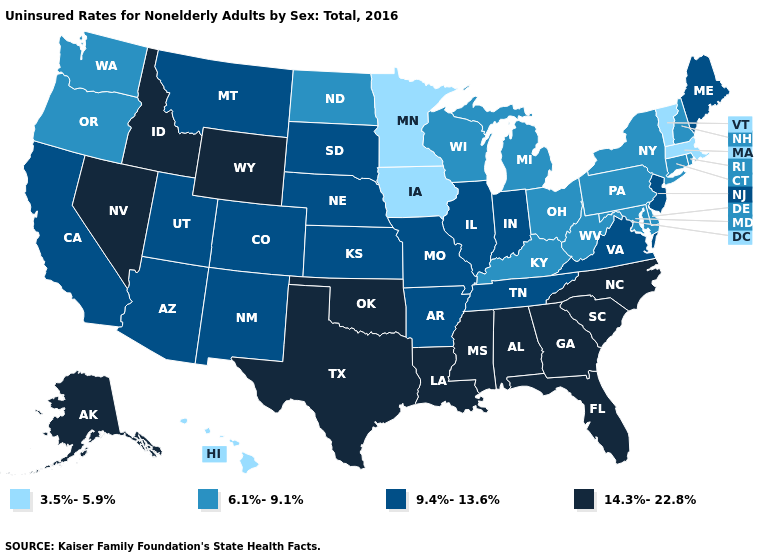Name the states that have a value in the range 9.4%-13.6%?
Quick response, please. Arizona, Arkansas, California, Colorado, Illinois, Indiana, Kansas, Maine, Missouri, Montana, Nebraska, New Jersey, New Mexico, South Dakota, Tennessee, Utah, Virginia. Name the states that have a value in the range 6.1%-9.1%?
Concise answer only. Connecticut, Delaware, Kentucky, Maryland, Michigan, New Hampshire, New York, North Dakota, Ohio, Oregon, Pennsylvania, Rhode Island, Washington, West Virginia, Wisconsin. Does Massachusetts have a higher value than Pennsylvania?
Answer briefly. No. What is the value of Kentucky?
Answer briefly. 6.1%-9.1%. Does the map have missing data?
Write a very short answer. No. What is the value of Wyoming?
Be succinct. 14.3%-22.8%. What is the value of Vermont?
Be succinct. 3.5%-5.9%. Does Illinois have the same value as South Carolina?
Short answer required. No. Name the states that have a value in the range 6.1%-9.1%?
Give a very brief answer. Connecticut, Delaware, Kentucky, Maryland, Michigan, New Hampshire, New York, North Dakota, Ohio, Oregon, Pennsylvania, Rhode Island, Washington, West Virginia, Wisconsin. Which states have the lowest value in the Northeast?
Quick response, please. Massachusetts, Vermont. Name the states that have a value in the range 3.5%-5.9%?
Write a very short answer. Hawaii, Iowa, Massachusetts, Minnesota, Vermont. Name the states that have a value in the range 3.5%-5.9%?
Answer briefly. Hawaii, Iowa, Massachusetts, Minnesota, Vermont. Name the states that have a value in the range 9.4%-13.6%?
Short answer required. Arizona, Arkansas, California, Colorado, Illinois, Indiana, Kansas, Maine, Missouri, Montana, Nebraska, New Jersey, New Mexico, South Dakota, Tennessee, Utah, Virginia. Does Louisiana have the lowest value in the USA?
Quick response, please. No. Which states have the lowest value in the USA?
Answer briefly. Hawaii, Iowa, Massachusetts, Minnesota, Vermont. 